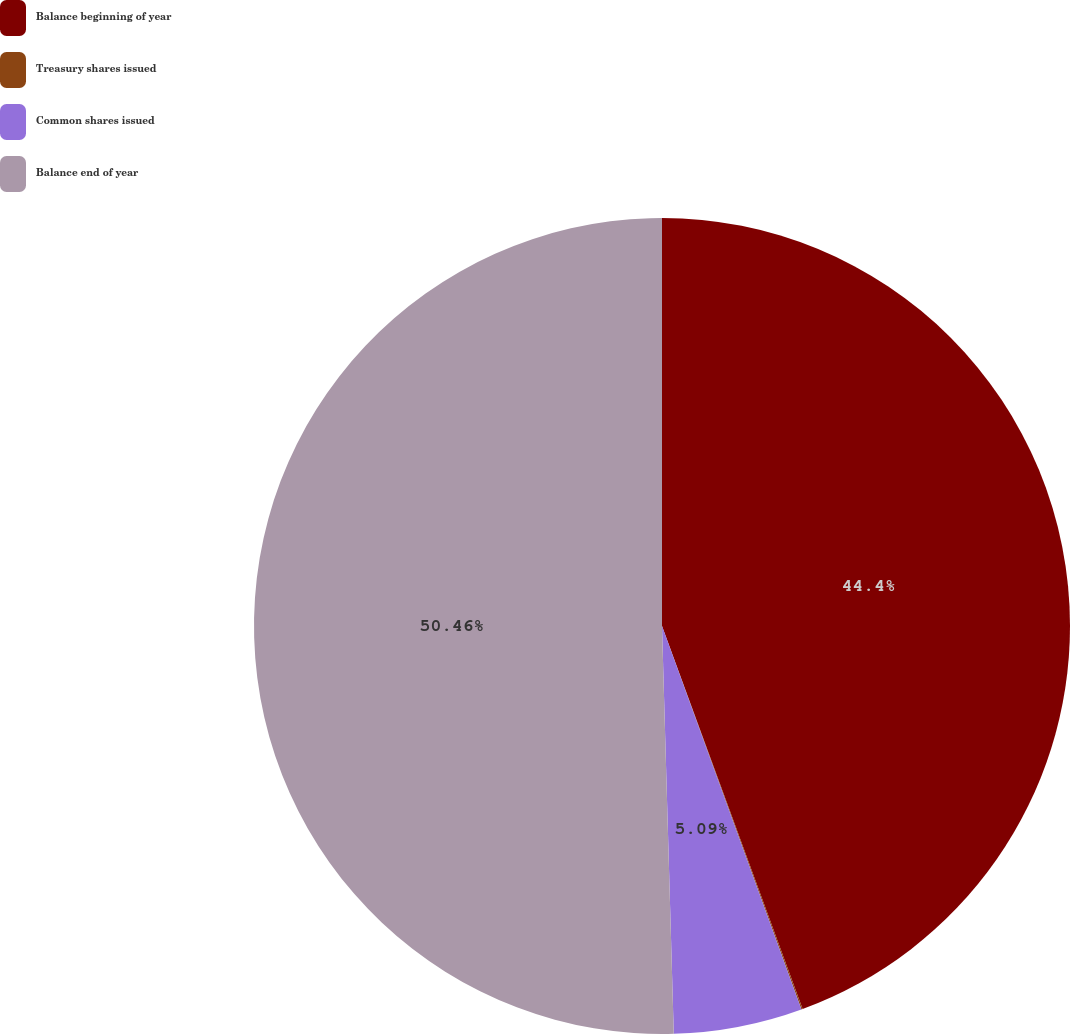<chart> <loc_0><loc_0><loc_500><loc_500><pie_chart><fcel>Balance beginning of year<fcel>Treasury shares issued<fcel>Common shares issued<fcel>Balance end of year<nl><fcel>44.4%<fcel>0.05%<fcel>5.09%<fcel>50.46%<nl></chart> 